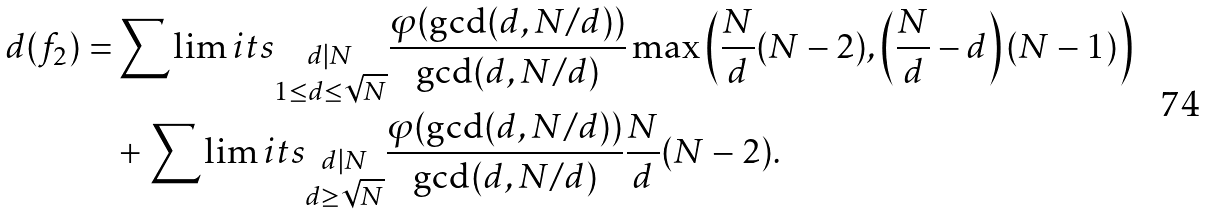Convert formula to latex. <formula><loc_0><loc_0><loc_500><loc_500>d ( f _ { 2 } ) = & \sum \lim i t s _ { \substack { d | N \\ 1 \leq d \leq \sqrt { N } } } \frac { \varphi ( \gcd ( d , N / d ) ) } { \gcd ( d , N / d ) } \max { \left ( \frac { N } { d } ( N - 2 ) , \left ( \frac { N } { d } - d \right ) ( N - 1 ) \right ) } \\ & + \sum \lim i t s _ { \substack { d | N \\ d \geq \sqrt { N } } } \frac { \varphi ( \gcd ( d , N / d ) ) } { \gcd ( d , N / d ) } \frac { N } { d } ( N - 2 ) .</formula> 